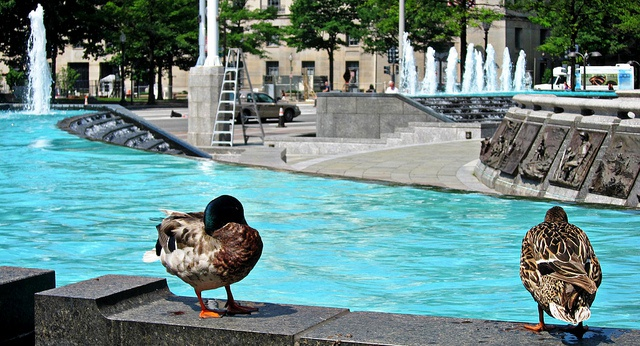Describe the objects in this image and their specific colors. I can see bird in black, maroon, gray, and lightgray tones, bird in black, maroon, and gray tones, truck in black, white, lightblue, and darkgray tones, car in black, gray, and darkgray tones, and traffic light in black, gray, blue, and darkgray tones in this image. 